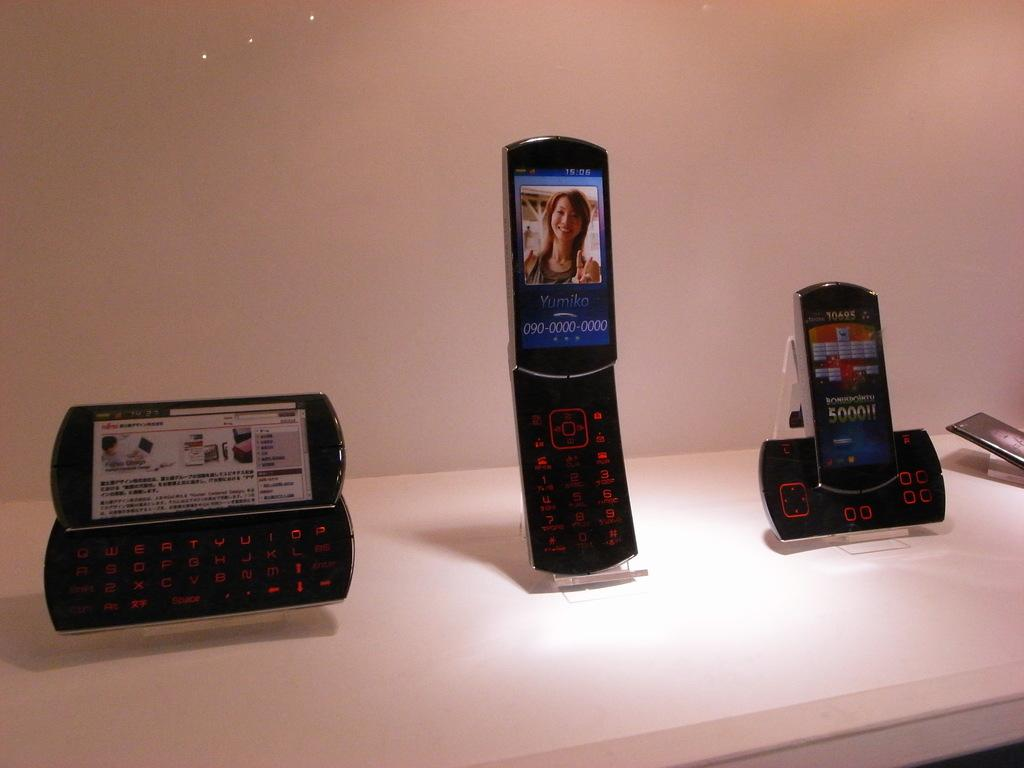How many mobiles are visible in the image? There are four mobiles in the image. What is the color of the surface on which the mobiles are placed? The mobiles are on a white surface. What type of blood vessels can be seen in the image? There are no blood vessels present in the image; it features four mobiles on a white surface. 